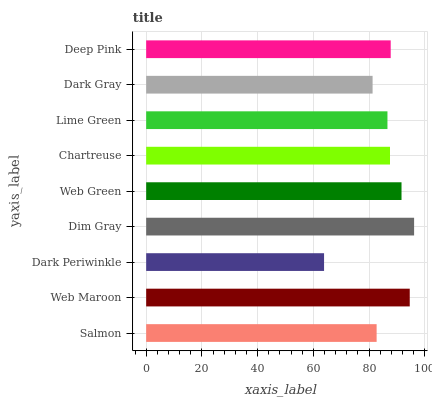Is Dark Periwinkle the minimum?
Answer yes or no. Yes. Is Dim Gray the maximum?
Answer yes or no. Yes. Is Web Maroon the minimum?
Answer yes or no. No. Is Web Maroon the maximum?
Answer yes or no. No. Is Web Maroon greater than Salmon?
Answer yes or no. Yes. Is Salmon less than Web Maroon?
Answer yes or no. Yes. Is Salmon greater than Web Maroon?
Answer yes or no. No. Is Web Maroon less than Salmon?
Answer yes or no. No. Is Chartreuse the high median?
Answer yes or no. Yes. Is Chartreuse the low median?
Answer yes or no. Yes. Is Deep Pink the high median?
Answer yes or no. No. Is Lime Green the low median?
Answer yes or no. No. 